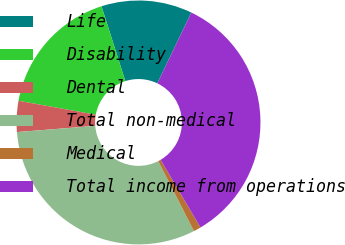Convert chart. <chart><loc_0><loc_0><loc_500><loc_500><pie_chart><fcel>Life<fcel>Disability<fcel>Dental<fcel>Total non-medical<fcel>Medical<fcel>Total income from operations<nl><fcel>12.04%<fcel>17.25%<fcel>4.1%<fcel>31.25%<fcel>0.98%<fcel>34.38%<nl></chart> 